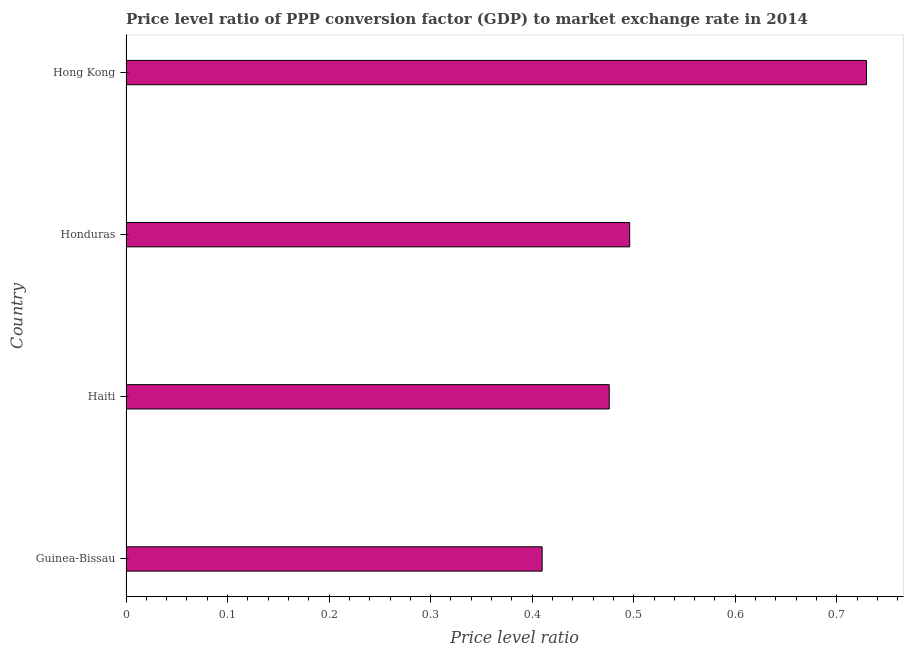Does the graph contain any zero values?
Your answer should be very brief. No. Does the graph contain grids?
Ensure brevity in your answer.  No. What is the title of the graph?
Offer a terse response. Price level ratio of PPP conversion factor (GDP) to market exchange rate in 2014. What is the label or title of the X-axis?
Provide a short and direct response. Price level ratio. What is the price level ratio in Haiti?
Your response must be concise. 0.48. Across all countries, what is the maximum price level ratio?
Offer a very short reply. 0.73. Across all countries, what is the minimum price level ratio?
Your answer should be compact. 0.41. In which country was the price level ratio maximum?
Give a very brief answer. Hong Kong. In which country was the price level ratio minimum?
Give a very brief answer. Guinea-Bissau. What is the sum of the price level ratio?
Ensure brevity in your answer.  2.11. What is the difference between the price level ratio in Guinea-Bissau and Hong Kong?
Keep it short and to the point. -0.32. What is the average price level ratio per country?
Provide a succinct answer. 0.53. What is the median price level ratio?
Offer a terse response. 0.49. What is the ratio of the price level ratio in Guinea-Bissau to that in Honduras?
Provide a short and direct response. 0.83. Is the price level ratio in Haiti less than that in Hong Kong?
Make the answer very short. Yes. What is the difference between the highest and the second highest price level ratio?
Offer a terse response. 0.23. Is the sum of the price level ratio in Guinea-Bissau and Honduras greater than the maximum price level ratio across all countries?
Your response must be concise. Yes. What is the difference between the highest and the lowest price level ratio?
Ensure brevity in your answer.  0.32. In how many countries, is the price level ratio greater than the average price level ratio taken over all countries?
Give a very brief answer. 1. How many bars are there?
Provide a succinct answer. 4. How many countries are there in the graph?
Your answer should be very brief. 4. What is the Price level ratio of Guinea-Bissau?
Your answer should be very brief. 0.41. What is the Price level ratio of Haiti?
Offer a terse response. 0.48. What is the Price level ratio in Honduras?
Give a very brief answer. 0.5. What is the Price level ratio of Hong Kong?
Provide a succinct answer. 0.73. What is the difference between the Price level ratio in Guinea-Bissau and Haiti?
Offer a terse response. -0.07. What is the difference between the Price level ratio in Guinea-Bissau and Honduras?
Offer a very short reply. -0.09. What is the difference between the Price level ratio in Guinea-Bissau and Hong Kong?
Keep it short and to the point. -0.32. What is the difference between the Price level ratio in Haiti and Honduras?
Your answer should be very brief. -0.02. What is the difference between the Price level ratio in Haiti and Hong Kong?
Keep it short and to the point. -0.25. What is the difference between the Price level ratio in Honduras and Hong Kong?
Provide a short and direct response. -0.23. What is the ratio of the Price level ratio in Guinea-Bissau to that in Haiti?
Make the answer very short. 0.86. What is the ratio of the Price level ratio in Guinea-Bissau to that in Honduras?
Your response must be concise. 0.83. What is the ratio of the Price level ratio in Guinea-Bissau to that in Hong Kong?
Your answer should be very brief. 0.56. What is the ratio of the Price level ratio in Haiti to that in Honduras?
Keep it short and to the point. 0.96. What is the ratio of the Price level ratio in Haiti to that in Hong Kong?
Keep it short and to the point. 0.65. What is the ratio of the Price level ratio in Honduras to that in Hong Kong?
Your answer should be compact. 0.68. 